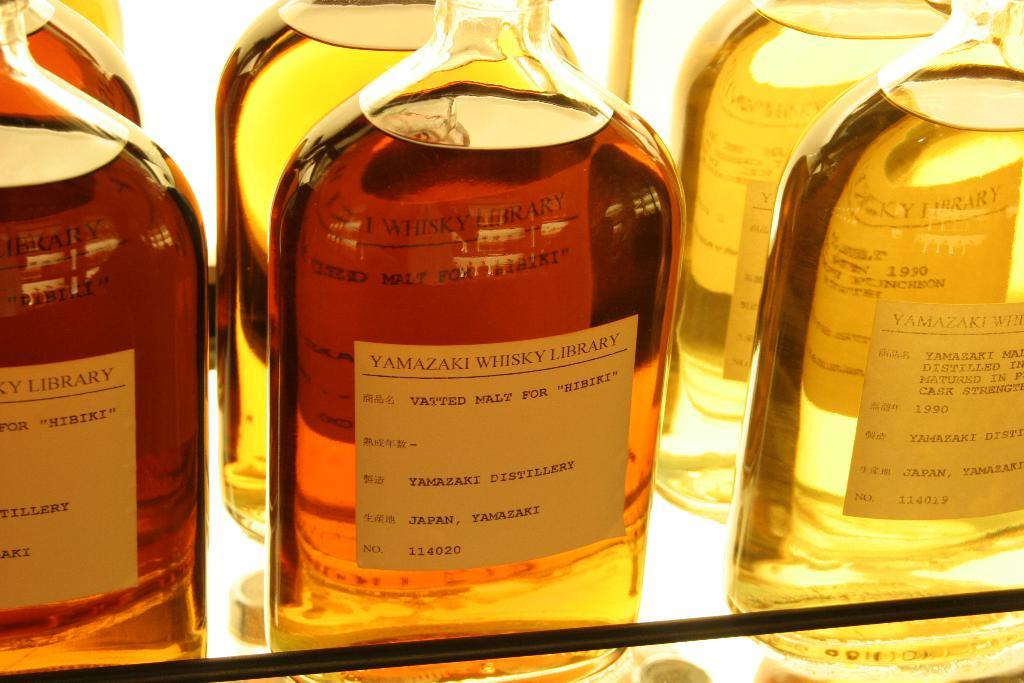What type of objects are grouped together in the image? There is a group of glass bottles in the image. What is the bottles resting on? The bottles are on an object. What is inside the bottles? There is liquid in the bottles. Are there any decorations or labels on the bottles? Yes, there are stickers on the bottles. Can you see your aunt flying with a wing in the image? There is no person, wing, or any reference to an aunt in the image; it only features a group of glass bottles. 